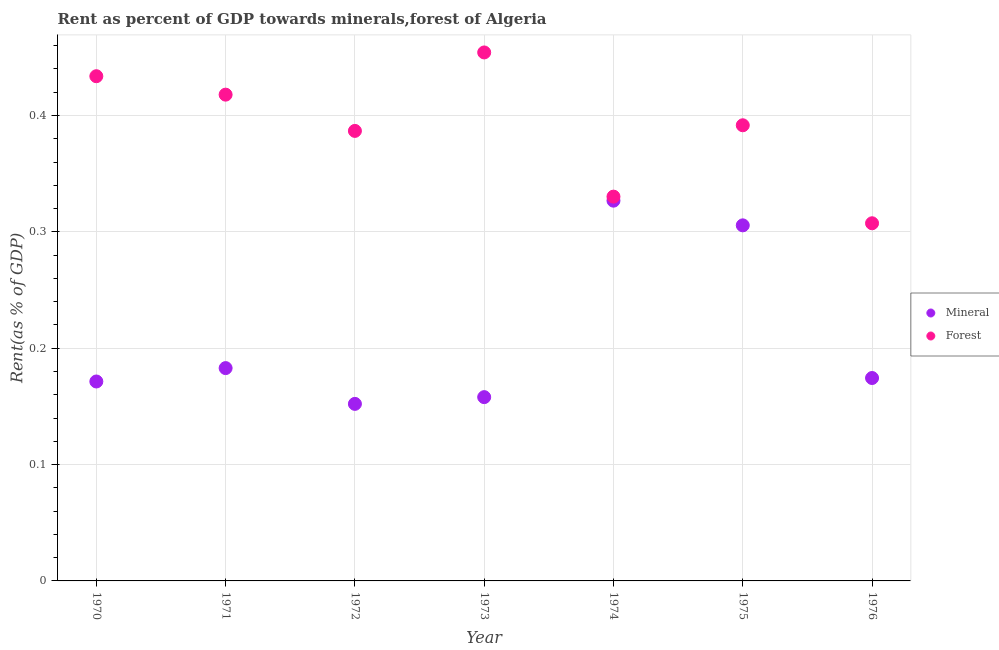How many different coloured dotlines are there?
Your answer should be very brief. 2. What is the mineral rent in 1975?
Offer a very short reply. 0.31. Across all years, what is the maximum forest rent?
Offer a very short reply. 0.45. Across all years, what is the minimum forest rent?
Your answer should be compact. 0.31. In which year was the mineral rent maximum?
Provide a short and direct response. 1974. In which year was the forest rent minimum?
Give a very brief answer. 1976. What is the total forest rent in the graph?
Keep it short and to the point. 2.72. What is the difference between the forest rent in 1970 and that in 1975?
Provide a short and direct response. 0.04. What is the difference between the mineral rent in 1975 and the forest rent in 1974?
Offer a terse response. -0.02. What is the average forest rent per year?
Offer a very short reply. 0.39. In the year 1972, what is the difference between the mineral rent and forest rent?
Your answer should be very brief. -0.23. What is the ratio of the mineral rent in 1972 to that in 1975?
Offer a terse response. 0.5. Is the forest rent in 1971 less than that in 1972?
Provide a succinct answer. No. What is the difference between the highest and the second highest forest rent?
Your answer should be very brief. 0.02. What is the difference between the highest and the lowest mineral rent?
Your response must be concise. 0.17. Is the sum of the forest rent in 1971 and 1972 greater than the maximum mineral rent across all years?
Offer a very short reply. Yes. Does the forest rent monotonically increase over the years?
Make the answer very short. No. Is the forest rent strictly less than the mineral rent over the years?
Provide a short and direct response. No. How many dotlines are there?
Offer a terse response. 2. How many years are there in the graph?
Your response must be concise. 7. What is the difference between two consecutive major ticks on the Y-axis?
Ensure brevity in your answer.  0.1. Are the values on the major ticks of Y-axis written in scientific E-notation?
Your response must be concise. No. Does the graph contain any zero values?
Make the answer very short. No. How are the legend labels stacked?
Your answer should be compact. Vertical. What is the title of the graph?
Provide a short and direct response. Rent as percent of GDP towards minerals,forest of Algeria. Does "Primary completion rate" appear as one of the legend labels in the graph?
Ensure brevity in your answer.  No. What is the label or title of the X-axis?
Provide a succinct answer. Year. What is the label or title of the Y-axis?
Make the answer very short. Rent(as % of GDP). What is the Rent(as % of GDP) in Mineral in 1970?
Make the answer very short. 0.17. What is the Rent(as % of GDP) in Forest in 1970?
Your answer should be very brief. 0.43. What is the Rent(as % of GDP) in Mineral in 1971?
Your answer should be compact. 0.18. What is the Rent(as % of GDP) of Forest in 1971?
Make the answer very short. 0.42. What is the Rent(as % of GDP) in Mineral in 1972?
Ensure brevity in your answer.  0.15. What is the Rent(as % of GDP) in Forest in 1972?
Keep it short and to the point. 0.39. What is the Rent(as % of GDP) of Mineral in 1973?
Provide a succinct answer. 0.16. What is the Rent(as % of GDP) in Forest in 1973?
Offer a terse response. 0.45. What is the Rent(as % of GDP) in Mineral in 1974?
Provide a short and direct response. 0.33. What is the Rent(as % of GDP) of Forest in 1974?
Make the answer very short. 0.33. What is the Rent(as % of GDP) of Mineral in 1975?
Your answer should be very brief. 0.31. What is the Rent(as % of GDP) of Forest in 1975?
Make the answer very short. 0.39. What is the Rent(as % of GDP) of Mineral in 1976?
Your answer should be very brief. 0.17. What is the Rent(as % of GDP) of Forest in 1976?
Offer a terse response. 0.31. Across all years, what is the maximum Rent(as % of GDP) in Mineral?
Your response must be concise. 0.33. Across all years, what is the maximum Rent(as % of GDP) in Forest?
Offer a very short reply. 0.45. Across all years, what is the minimum Rent(as % of GDP) in Mineral?
Your answer should be very brief. 0.15. Across all years, what is the minimum Rent(as % of GDP) of Forest?
Offer a very short reply. 0.31. What is the total Rent(as % of GDP) in Mineral in the graph?
Your answer should be compact. 1.47. What is the total Rent(as % of GDP) of Forest in the graph?
Give a very brief answer. 2.72. What is the difference between the Rent(as % of GDP) in Mineral in 1970 and that in 1971?
Offer a terse response. -0.01. What is the difference between the Rent(as % of GDP) in Forest in 1970 and that in 1971?
Offer a very short reply. 0.02. What is the difference between the Rent(as % of GDP) in Mineral in 1970 and that in 1972?
Your response must be concise. 0.02. What is the difference between the Rent(as % of GDP) in Forest in 1970 and that in 1972?
Your answer should be very brief. 0.05. What is the difference between the Rent(as % of GDP) in Mineral in 1970 and that in 1973?
Provide a succinct answer. 0.01. What is the difference between the Rent(as % of GDP) of Forest in 1970 and that in 1973?
Your answer should be compact. -0.02. What is the difference between the Rent(as % of GDP) of Mineral in 1970 and that in 1974?
Your answer should be very brief. -0.16. What is the difference between the Rent(as % of GDP) of Forest in 1970 and that in 1974?
Make the answer very short. 0.1. What is the difference between the Rent(as % of GDP) of Mineral in 1970 and that in 1975?
Your answer should be compact. -0.13. What is the difference between the Rent(as % of GDP) in Forest in 1970 and that in 1975?
Your answer should be compact. 0.04. What is the difference between the Rent(as % of GDP) of Mineral in 1970 and that in 1976?
Make the answer very short. -0. What is the difference between the Rent(as % of GDP) in Forest in 1970 and that in 1976?
Offer a very short reply. 0.13. What is the difference between the Rent(as % of GDP) of Mineral in 1971 and that in 1972?
Offer a very short reply. 0.03. What is the difference between the Rent(as % of GDP) of Forest in 1971 and that in 1972?
Offer a terse response. 0.03. What is the difference between the Rent(as % of GDP) of Mineral in 1971 and that in 1973?
Provide a short and direct response. 0.03. What is the difference between the Rent(as % of GDP) of Forest in 1971 and that in 1973?
Provide a short and direct response. -0.04. What is the difference between the Rent(as % of GDP) in Mineral in 1971 and that in 1974?
Keep it short and to the point. -0.14. What is the difference between the Rent(as % of GDP) in Forest in 1971 and that in 1974?
Provide a succinct answer. 0.09. What is the difference between the Rent(as % of GDP) in Mineral in 1971 and that in 1975?
Keep it short and to the point. -0.12. What is the difference between the Rent(as % of GDP) in Forest in 1971 and that in 1975?
Your answer should be compact. 0.03. What is the difference between the Rent(as % of GDP) of Mineral in 1971 and that in 1976?
Keep it short and to the point. 0.01. What is the difference between the Rent(as % of GDP) of Forest in 1971 and that in 1976?
Offer a terse response. 0.11. What is the difference between the Rent(as % of GDP) of Mineral in 1972 and that in 1973?
Offer a terse response. -0.01. What is the difference between the Rent(as % of GDP) in Forest in 1972 and that in 1973?
Your answer should be very brief. -0.07. What is the difference between the Rent(as % of GDP) in Mineral in 1972 and that in 1974?
Offer a terse response. -0.17. What is the difference between the Rent(as % of GDP) in Forest in 1972 and that in 1974?
Offer a terse response. 0.06. What is the difference between the Rent(as % of GDP) of Mineral in 1972 and that in 1975?
Give a very brief answer. -0.15. What is the difference between the Rent(as % of GDP) in Forest in 1972 and that in 1975?
Provide a short and direct response. -0. What is the difference between the Rent(as % of GDP) in Mineral in 1972 and that in 1976?
Offer a terse response. -0.02. What is the difference between the Rent(as % of GDP) of Forest in 1972 and that in 1976?
Make the answer very short. 0.08. What is the difference between the Rent(as % of GDP) of Mineral in 1973 and that in 1974?
Your answer should be compact. -0.17. What is the difference between the Rent(as % of GDP) of Forest in 1973 and that in 1974?
Offer a terse response. 0.12. What is the difference between the Rent(as % of GDP) of Mineral in 1973 and that in 1975?
Offer a very short reply. -0.15. What is the difference between the Rent(as % of GDP) in Forest in 1973 and that in 1975?
Provide a short and direct response. 0.06. What is the difference between the Rent(as % of GDP) of Mineral in 1973 and that in 1976?
Provide a short and direct response. -0.02. What is the difference between the Rent(as % of GDP) in Forest in 1973 and that in 1976?
Keep it short and to the point. 0.15. What is the difference between the Rent(as % of GDP) in Mineral in 1974 and that in 1975?
Keep it short and to the point. 0.02. What is the difference between the Rent(as % of GDP) of Forest in 1974 and that in 1975?
Offer a very short reply. -0.06. What is the difference between the Rent(as % of GDP) of Mineral in 1974 and that in 1976?
Offer a very short reply. 0.15. What is the difference between the Rent(as % of GDP) of Forest in 1974 and that in 1976?
Your response must be concise. 0.02. What is the difference between the Rent(as % of GDP) in Mineral in 1975 and that in 1976?
Provide a succinct answer. 0.13. What is the difference between the Rent(as % of GDP) of Forest in 1975 and that in 1976?
Your answer should be very brief. 0.08. What is the difference between the Rent(as % of GDP) in Mineral in 1970 and the Rent(as % of GDP) in Forest in 1971?
Your answer should be compact. -0.25. What is the difference between the Rent(as % of GDP) in Mineral in 1970 and the Rent(as % of GDP) in Forest in 1972?
Give a very brief answer. -0.22. What is the difference between the Rent(as % of GDP) in Mineral in 1970 and the Rent(as % of GDP) in Forest in 1973?
Keep it short and to the point. -0.28. What is the difference between the Rent(as % of GDP) of Mineral in 1970 and the Rent(as % of GDP) of Forest in 1974?
Your answer should be very brief. -0.16. What is the difference between the Rent(as % of GDP) of Mineral in 1970 and the Rent(as % of GDP) of Forest in 1975?
Make the answer very short. -0.22. What is the difference between the Rent(as % of GDP) of Mineral in 1970 and the Rent(as % of GDP) of Forest in 1976?
Provide a short and direct response. -0.14. What is the difference between the Rent(as % of GDP) of Mineral in 1971 and the Rent(as % of GDP) of Forest in 1972?
Your answer should be compact. -0.2. What is the difference between the Rent(as % of GDP) in Mineral in 1971 and the Rent(as % of GDP) in Forest in 1973?
Offer a very short reply. -0.27. What is the difference between the Rent(as % of GDP) in Mineral in 1971 and the Rent(as % of GDP) in Forest in 1974?
Your answer should be very brief. -0.15. What is the difference between the Rent(as % of GDP) in Mineral in 1971 and the Rent(as % of GDP) in Forest in 1975?
Your answer should be very brief. -0.21. What is the difference between the Rent(as % of GDP) in Mineral in 1971 and the Rent(as % of GDP) in Forest in 1976?
Make the answer very short. -0.12. What is the difference between the Rent(as % of GDP) in Mineral in 1972 and the Rent(as % of GDP) in Forest in 1973?
Ensure brevity in your answer.  -0.3. What is the difference between the Rent(as % of GDP) in Mineral in 1972 and the Rent(as % of GDP) in Forest in 1974?
Provide a short and direct response. -0.18. What is the difference between the Rent(as % of GDP) of Mineral in 1972 and the Rent(as % of GDP) of Forest in 1975?
Offer a terse response. -0.24. What is the difference between the Rent(as % of GDP) in Mineral in 1972 and the Rent(as % of GDP) in Forest in 1976?
Offer a terse response. -0.16. What is the difference between the Rent(as % of GDP) in Mineral in 1973 and the Rent(as % of GDP) in Forest in 1974?
Ensure brevity in your answer.  -0.17. What is the difference between the Rent(as % of GDP) in Mineral in 1973 and the Rent(as % of GDP) in Forest in 1975?
Offer a very short reply. -0.23. What is the difference between the Rent(as % of GDP) of Mineral in 1973 and the Rent(as % of GDP) of Forest in 1976?
Keep it short and to the point. -0.15. What is the difference between the Rent(as % of GDP) of Mineral in 1974 and the Rent(as % of GDP) of Forest in 1975?
Make the answer very short. -0.06. What is the difference between the Rent(as % of GDP) of Mineral in 1974 and the Rent(as % of GDP) of Forest in 1976?
Your response must be concise. 0.02. What is the difference between the Rent(as % of GDP) of Mineral in 1975 and the Rent(as % of GDP) of Forest in 1976?
Your answer should be very brief. -0. What is the average Rent(as % of GDP) of Mineral per year?
Your response must be concise. 0.21. What is the average Rent(as % of GDP) of Forest per year?
Ensure brevity in your answer.  0.39. In the year 1970, what is the difference between the Rent(as % of GDP) in Mineral and Rent(as % of GDP) in Forest?
Your response must be concise. -0.26. In the year 1971, what is the difference between the Rent(as % of GDP) of Mineral and Rent(as % of GDP) of Forest?
Ensure brevity in your answer.  -0.23. In the year 1972, what is the difference between the Rent(as % of GDP) of Mineral and Rent(as % of GDP) of Forest?
Keep it short and to the point. -0.23. In the year 1973, what is the difference between the Rent(as % of GDP) of Mineral and Rent(as % of GDP) of Forest?
Provide a succinct answer. -0.3. In the year 1974, what is the difference between the Rent(as % of GDP) in Mineral and Rent(as % of GDP) in Forest?
Provide a succinct answer. -0. In the year 1975, what is the difference between the Rent(as % of GDP) of Mineral and Rent(as % of GDP) of Forest?
Offer a terse response. -0.09. In the year 1976, what is the difference between the Rent(as % of GDP) of Mineral and Rent(as % of GDP) of Forest?
Offer a terse response. -0.13. What is the ratio of the Rent(as % of GDP) of Mineral in 1970 to that in 1971?
Your answer should be compact. 0.94. What is the ratio of the Rent(as % of GDP) in Forest in 1970 to that in 1971?
Give a very brief answer. 1.04. What is the ratio of the Rent(as % of GDP) of Mineral in 1970 to that in 1972?
Provide a succinct answer. 1.13. What is the ratio of the Rent(as % of GDP) in Forest in 1970 to that in 1972?
Ensure brevity in your answer.  1.12. What is the ratio of the Rent(as % of GDP) in Mineral in 1970 to that in 1973?
Provide a succinct answer. 1.09. What is the ratio of the Rent(as % of GDP) of Forest in 1970 to that in 1973?
Your response must be concise. 0.95. What is the ratio of the Rent(as % of GDP) of Mineral in 1970 to that in 1974?
Your answer should be very brief. 0.52. What is the ratio of the Rent(as % of GDP) of Forest in 1970 to that in 1974?
Your answer should be very brief. 1.31. What is the ratio of the Rent(as % of GDP) in Mineral in 1970 to that in 1975?
Offer a very short reply. 0.56. What is the ratio of the Rent(as % of GDP) of Forest in 1970 to that in 1975?
Give a very brief answer. 1.11. What is the ratio of the Rent(as % of GDP) of Mineral in 1970 to that in 1976?
Keep it short and to the point. 0.98. What is the ratio of the Rent(as % of GDP) of Forest in 1970 to that in 1976?
Offer a terse response. 1.41. What is the ratio of the Rent(as % of GDP) in Mineral in 1971 to that in 1972?
Ensure brevity in your answer.  1.2. What is the ratio of the Rent(as % of GDP) in Forest in 1971 to that in 1972?
Your answer should be very brief. 1.08. What is the ratio of the Rent(as % of GDP) of Mineral in 1971 to that in 1973?
Offer a very short reply. 1.16. What is the ratio of the Rent(as % of GDP) of Forest in 1971 to that in 1973?
Your answer should be very brief. 0.92. What is the ratio of the Rent(as % of GDP) in Mineral in 1971 to that in 1974?
Give a very brief answer. 0.56. What is the ratio of the Rent(as % of GDP) in Forest in 1971 to that in 1974?
Provide a short and direct response. 1.27. What is the ratio of the Rent(as % of GDP) in Mineral in 1971 to that in 1975?
Make the answer very short. 0.6. What is the ratio of the Rent(as % of GDP) in Forest in 1971 to that in 1975?
Offer a very short reply. 1.07. What is the ratio of the Rent(as % of GDP) in Mineral in 1971 to that in 1976?
Ensure brevity in your answer.  1.05. What is the ratio of the Rent(as % of GDP) of Forest in 1971 to that in 1976?
Offer a terse response. 1.36. What is the ratio of the Rent(as % of GDP) in Mineral in 1972 to that in 1973?
Provide a short and direct response. 0.96. What is the ratio of the Rent(as % of GDP) in Forest in 1972 to that in 1973?
Ensure brevity in your answer.  0.85. What is the ratio of the Rent(as % of GDP) of Mineral in 1972 to that in 1974?
Your answer should be compact. 0.47. What is the ratio of the Rent(as % of GDP) in Forest in 1972 to that in 1974?
Your answer should be compact. 1.17. What is the ratio of the Rent(as % of GDP) of Mineral in 1972 to that in 1975?
Keep it short and to the point. 0.5. What is the ratio of the Rent(as % of GDP) of Forest in 1972 to that in 1975?
Keep it short and to the point. 0.99. What is the ratio of the Rent(as % of GDP) in Mineral in 1972 to that in 1976?
Keep it short and to the point. 0.87. What is the ratio of the Rent(as % of GDP) in Forest in 1972 to that in 1976?
Your response must be concise. 1.26. What is the ratio of the Rent(as % of GDP) of Mineral in 1973 to that in 1974?
Ensure brevity in your answer.  0.48. What is the ratio of the Rent(as % of GDP) of Forest in 1973 to that in 1974?
Provide a short and direct response. 1.38. What is the ratio of the Rent(as % of GDP) in Mineral in 1973 to that in 1975?
Provide a succinct answer. 0.52. What is the ratio of the Rent(as % of GDP) of Forest in 1973 to that in 1975?
Offer a terse response. 1.16. What is the ratio of the Rent(as % of GDP) of Mineral in 1973 to that in 1976?
Make the answer very short. 0.91. What is the ratio of the Rent(as % of GDP) in Forest in 1973 to that in 1976?
Provide a short and direct response. 1.48. What is the ratio of the Rent(as % of GDP) in Mineral in 1974 to that in 1975?
Provide a short and direct response. 1.07. What is the ratio of the Rent(as % of GDP) of Forest in 1974 to that in 1975?
Provide a succinct answer. 0.84. What is the ratio of the Rent(as % of GDP) of Mineral in 1974 to that in 1976?
Offer a very short reply. 1.87. What is the ratio of the Rent(as % of GDP) in Forest in 1974 to that in 1976?
Keep it short and to the point. 1.07. What is the ratio of the Rent(as % of GDP) in Mineral in 1975 to that in 1976?
Keep it short and to the point. 1.75. What is the ratio of the Rent(as % of GDP) of Forest in 1975 to that in 1976?
Provide a short and direct response. 1.27. What is the difference between the highest and the second highest Rent(as % of GDP) of Mineral?
Your response must be concise. 0.02. What is the difference between the highest and the second highest Rent(as % of GDP) of Forest?
Give a very brief answer. 0.02. What is the difference between the highest and the lowest Rent(as % of GDP) of Mineral?
Keep it short and to the point. 0.17. What is the difference between the highest and the lowest Rent(as % of GDP) of Forest?
Keep it short and to the point. 0.15. 